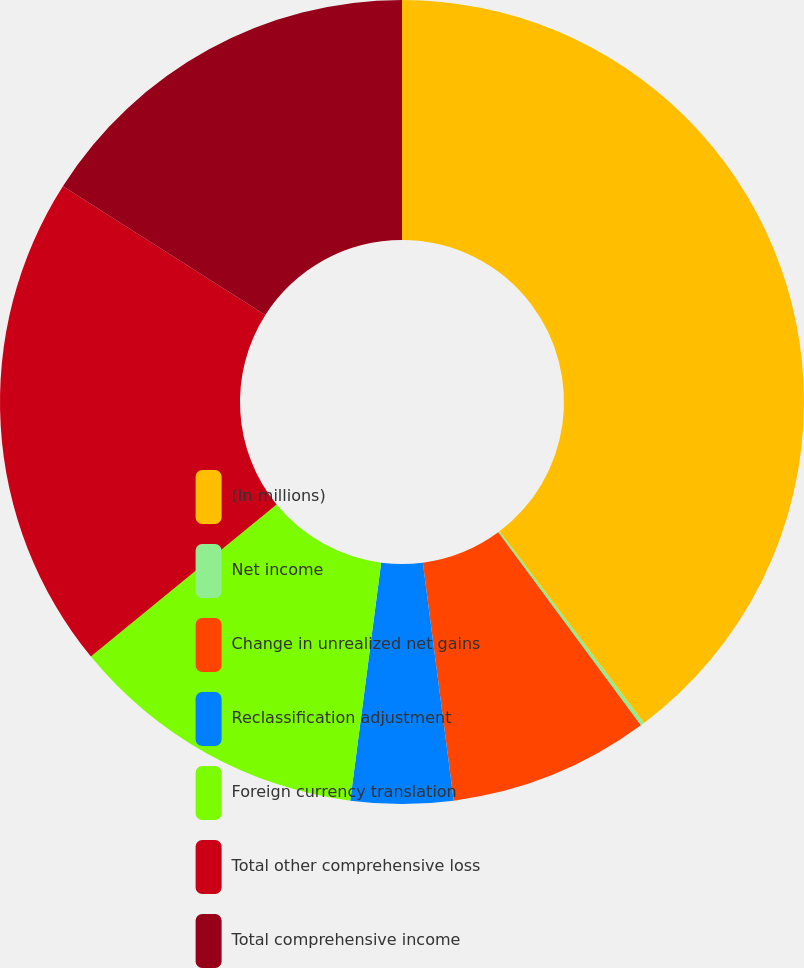Convert chart to OTSL. <chart><loc_0><loc_0><loc_500><loc_500><pie_chart><fcel>(In millions)<fcel>Net income<fcel>Change in unrealized net gains<fcel>Reclassification adjustment<fcel>Foreign currency translation<fcel>Total other comprehensive loss<fcel>Total comprehensive income<nl><fcel>39.72%<fcel>0.16%<fcel>8.07%<fcel>4.11%<fcel>12.03%<fcel>19.94%<fcel>15.98%<nl></chart> 